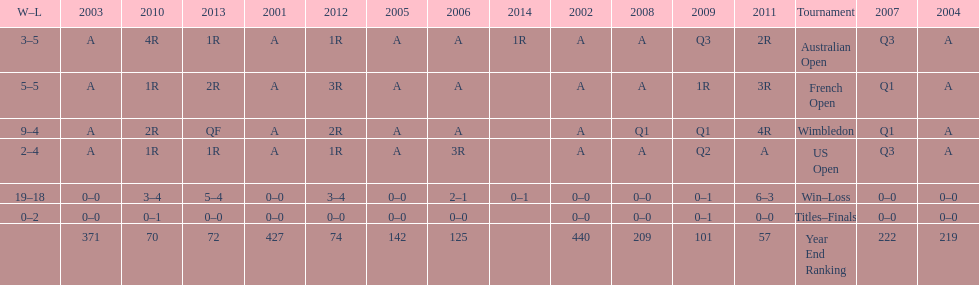In how many contests were 5 total losses experienced? 2. 